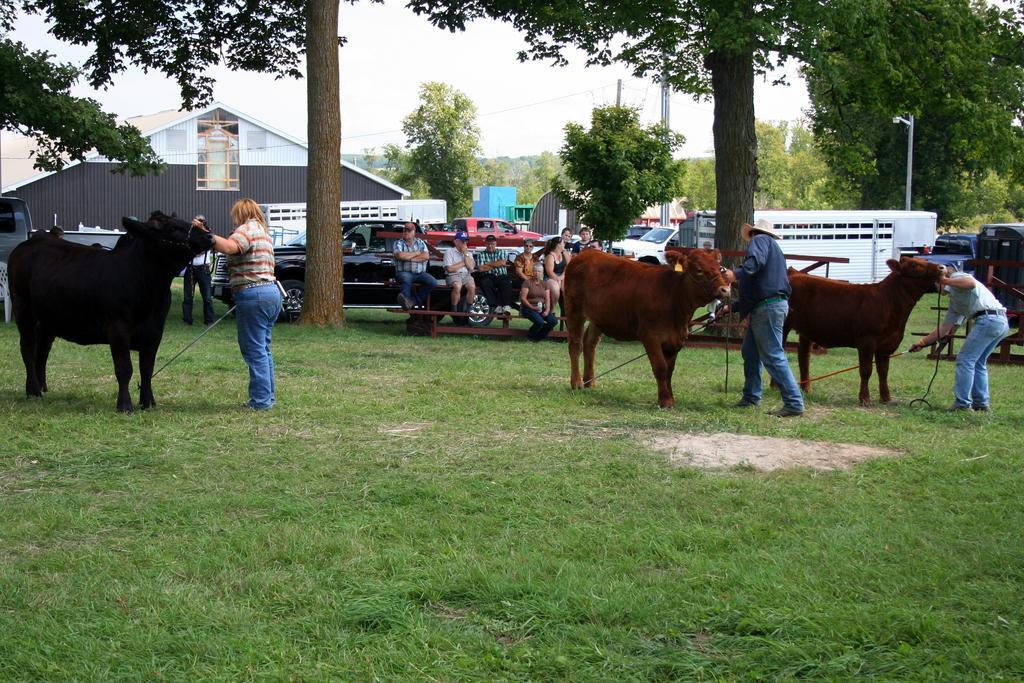Describe this image in one or two sentences. This image consists of animals and many persons. At the bottom, there is green grass. In the middle, there are many trees. To the left, there is a house. And there are many cars parked. At the top, there is a sky. 